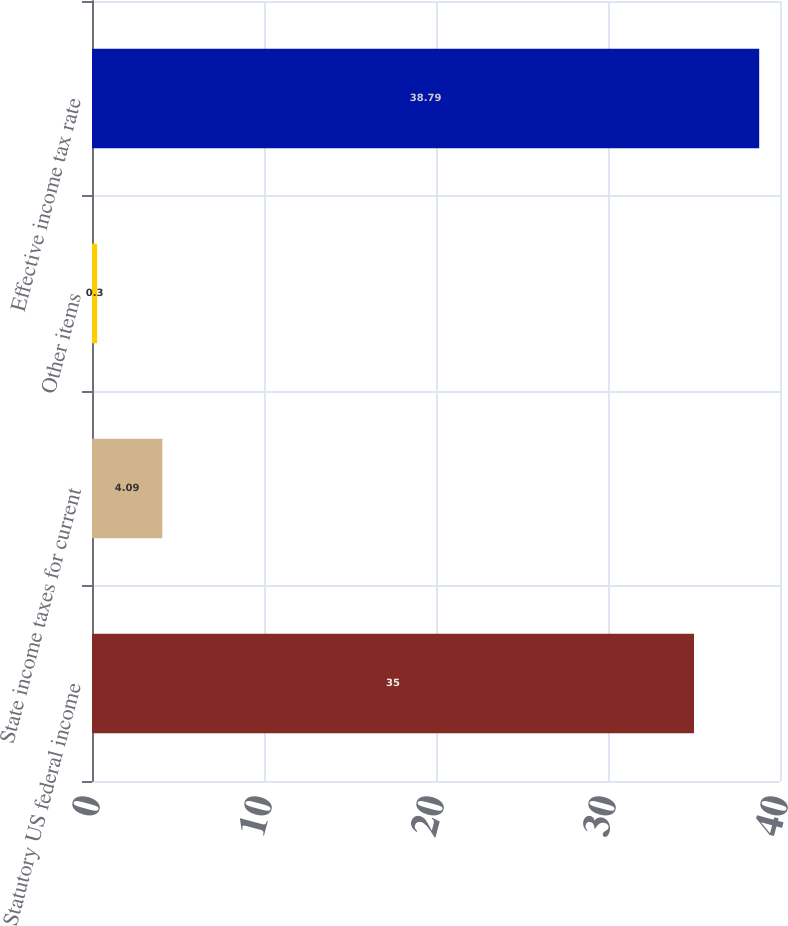<chart> <loc_0><loc_0><loc_500><loc_500><bar_chart><fcel>Statutory US federal income<fcel>State income taxes for current<fcel>Other items<fcel>Effective income tax rate<nl><fcel>35<fcel>4.09<fcel>0.3<fcel>38.79<nl></chart> 